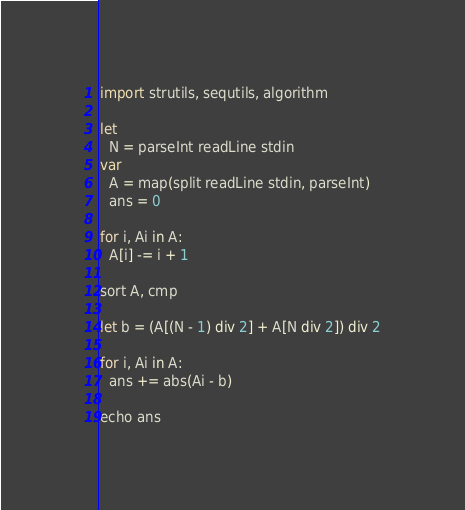<code> <loc_0><loc_0><loc_500><loc_500><_Nim_>import strutils, sequtils, algorithm

let
  N = parseInt readLine stdin
var
  A = map(split readLine stdin, parseInt)
  ans = 0

for i, Ai in A:
  A[i] -= i + 1

sort A, cmp

let b = (A[(N - 1) div 2] + A[N div 2]) div 2

for i, Ai in A:
  ans += abs(Ai - b)

echo ans
</code> 